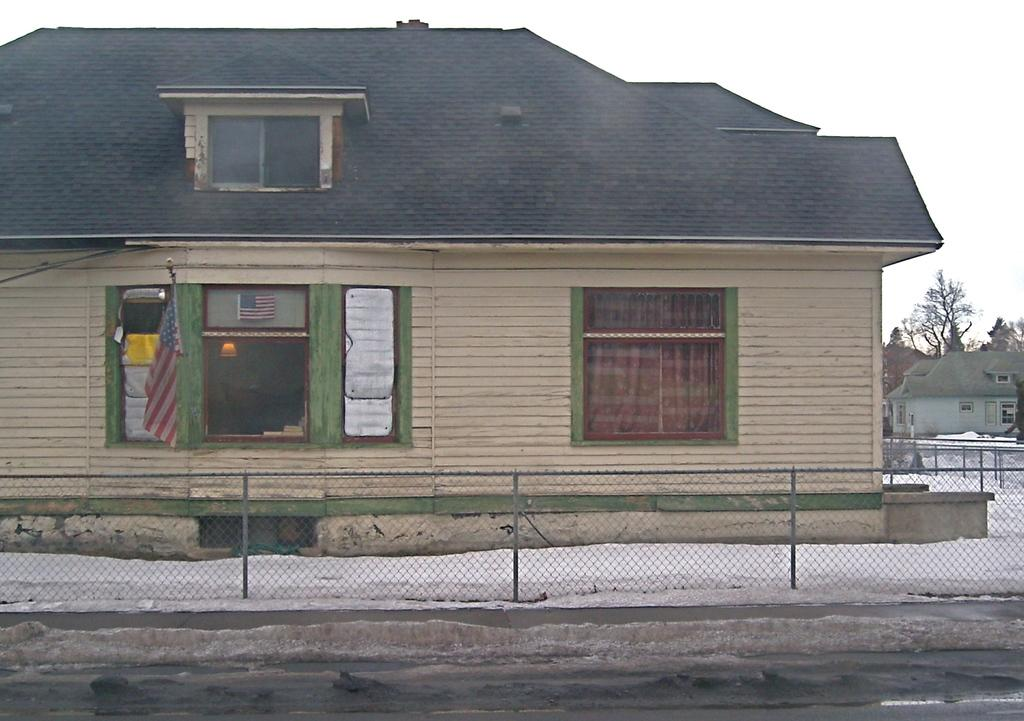What can be seen near the snow surface on the ground? There is a fencing near the snow surface on the ground. What type of structure is visible in the background? There is a house with a roof and glass windows in the background. Are there any other structures visible in the background? Yes, there are other houses in the background. What else can be seen in the background of the image? There are trees and the sky visible in the background. Can you see any bubbles in the image? There are no bubbles present in the image. How many toes are visible in the image? There are no toes visible in the image. 